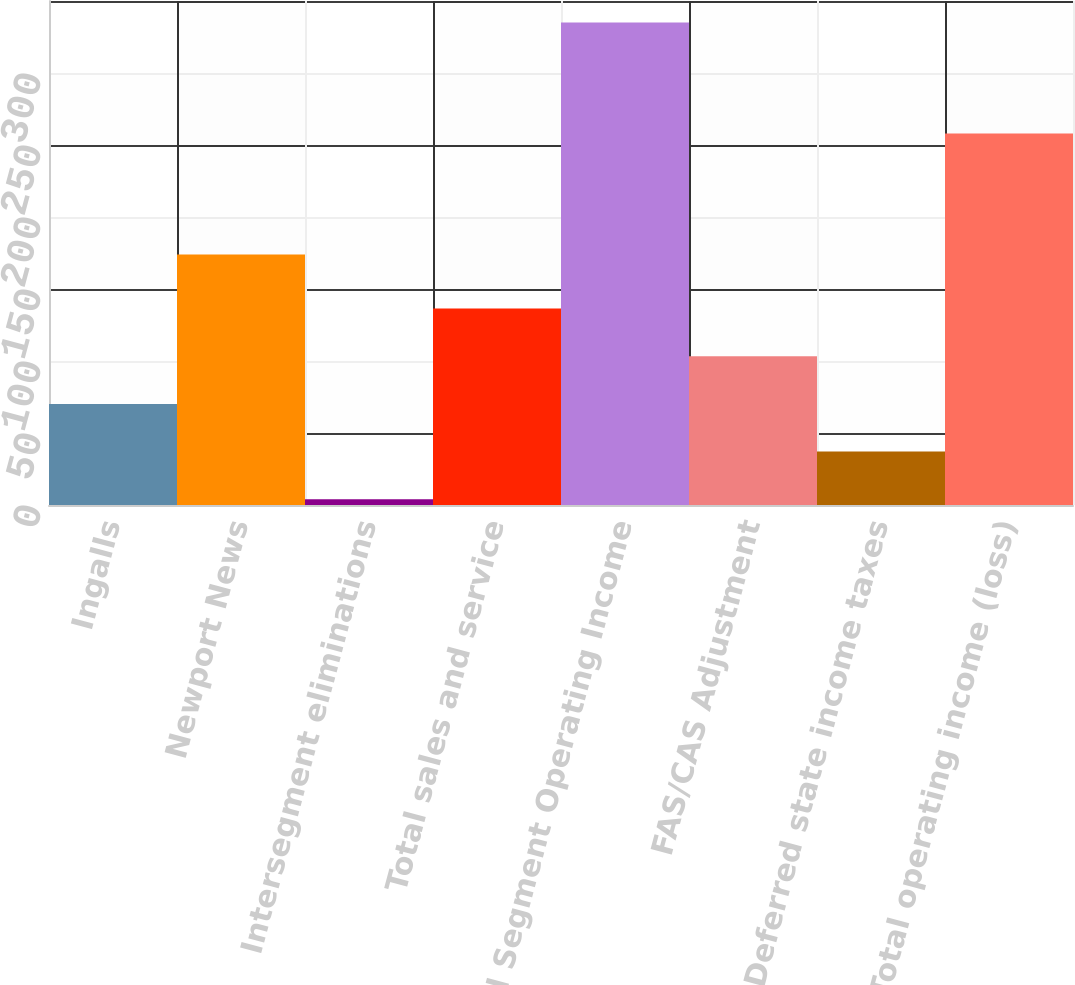Convert chart. <chart><loc_0><loc_0><loc_500><loc_500><bar_chart><fcel>Ingalls<fcel>Newport News<fcel>Intersegment eliminations<fcel>Total sales and service<fcel>Total Segment Operating Income<fcel>FAS/CAS Adjustment<fcel>Deferred state income taxes<fcel>Total operating income (loss)<nl><fcel>70.2<fcel>174<fcel>4<fcel>136.4<fcel>335<fcel>103.3<fcel>37.1<fcel>258<nl></chart> 